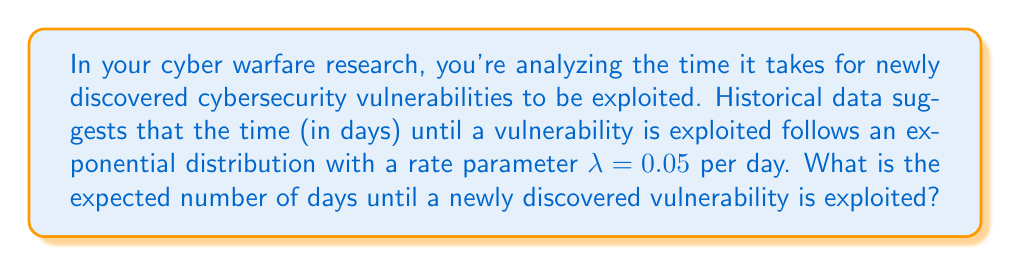Solve this math problem. Let's approach this step-by-step:

1) The exponential distribution is often used to model the time until an event occurs, making it suitable for this cybersecurity scenario.

2) For an exponential distribution with rate parameter λ, the expected value (mean) is given by:

   $$ E[X] = \frac{1}{\lambda} $$

3) We are given that λ = 0.05 per day.

4) Substituting this into our formula:

   $$ E[X] = \frac{1}{0.05} $$

5) Calculating this:

   $$ E[X] = 20 $$

Therefore, the expected time until a newly discovered vulnerability is exploited is 20 days.
Answer: 20 days 